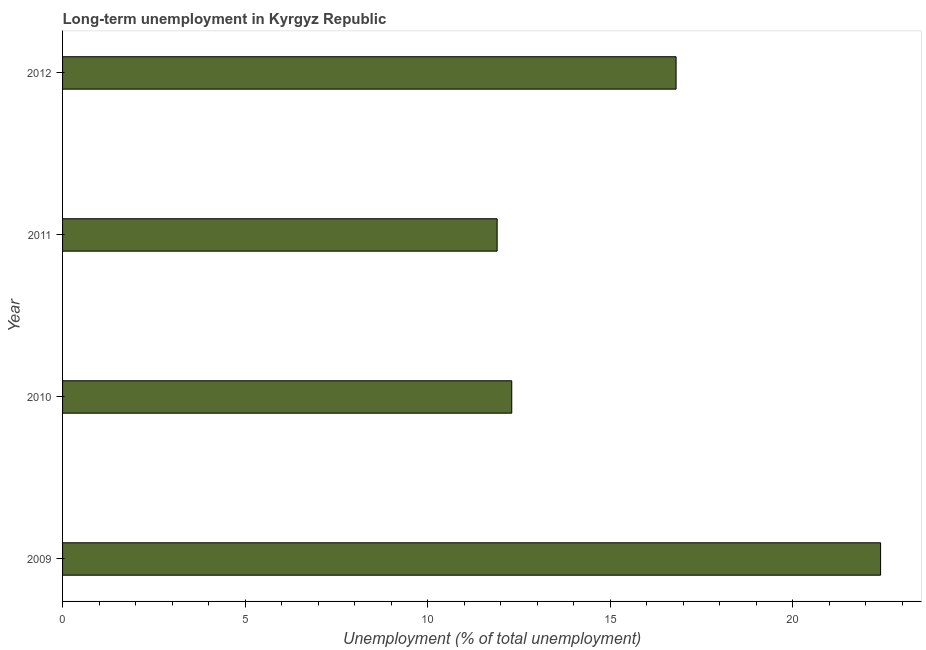Does the graph contain any zero values?
Keep it short and to the point. No. What is the title of the graph?
Offer a very short reply. Long-term unemployment in Kyrgyz Republic. What is the label or title of the X-axis?
Your answer should be compact. Unemployment (% of total unemployment). What is the long-term unemployment in 2009?
Provide a short and direct response. 22.4. Across all years, what is the maximum long-term unemployment?
Your answer should be very brief. 22.4. Across all years, what is the minimum long-term unemployment?
Make the answer very short. 11.9. In which year was the long-term unemployment minimum?
Make the answer very short. 2011. What is the sum of the long-term unemployment?
Provide a succinct answer. 63.4. What is the difference between the long-term unemployment in 2009 and 2010?
Offer a very short reply. 10.1. What is the average long-term unemployment per year?
Offer a very short reply. 15.85. What is the median long-term unemployment?
Your response must be concise. 14.55. In how many years, is the long-term unemployment greater than 17 %?
Your answer should be very brief. 1. What is the ratio of the long-term unemployment in 2010 to that in 2011?
Keep it short and to the point. 1.03. What is the difference between the highest and the second highest long-term unemployment?
Ensure brevity in your answer.  5.6. Is the sum of the long-term unemployment in 2009 and 2012 greater than the maximum long-term unemployment across all years?
Ensure brevity in your answer.  Yes. What is the difference between the highest and the lowest long-term unemployment?
Keep it short and to the point. 10.5. In how many years, is the long-term unemployment greater than the average long-term unemployment taken over all years?
Make the answer very short. 2. Are all the bars in the graph horizontal?
Your answer should be very brief. Yes. What is the Unemployment (% of total unemployment) of 2009?
Give a very brief answer. 22.4. What is the Unemployment (% of total unemployment) in 2010?
Ensure brevity in your answer.  12.3. What is the Unemployment (% of total unemployment) in 2011?
Offer a very short reply. 11.9. What is the Unemployment (% of total unemployment) in 2012?
Offer a terse response. 16.8. What is the difference between the Unemployment (% of total unemployment) in 2009 and 2010?
Your answer should be very brief. 10.1. What is the difference between the Unemployment (% of total unemployment) in 2009 and 2012?
Ensure brevity in your answer.  5.6. What is the difference between the Unemployment (% of total unemployment) in 2010 and 2012?
Your answer should be compact. -4.5. What is the difference between the Unemployment (% of total unemployment) in 2011 and 2012?
Provide a short and direct response. -4.9. What is the ratio of the Unemployment (% of total unemployment) in 2009 to that in 2010?
Your answer should be very brief. 1.82. What is the ratio of the Unemployment (% of total unemployment) in 2009 to that in 2011?
Offer a terse response. 1.88. What is the ratio of the Unemployment (% of total unemployment) in 2009 to that in 2012?
Your answer should be compact. 1.33. What is the ratio of the Unemployment (% of total unemployment) in 2010 to that in 2011?
Ensure brevity in your answer.  1.03. What is the ratio of the Unemployment (% of total unemployment) in 2010 to that in 2012?
Give a very brief answer. 0.73. What is the ratio of the Unemployment (% of total unemployment) in 2011 to that in 2012?
Offer a very short reply. 0.71. 